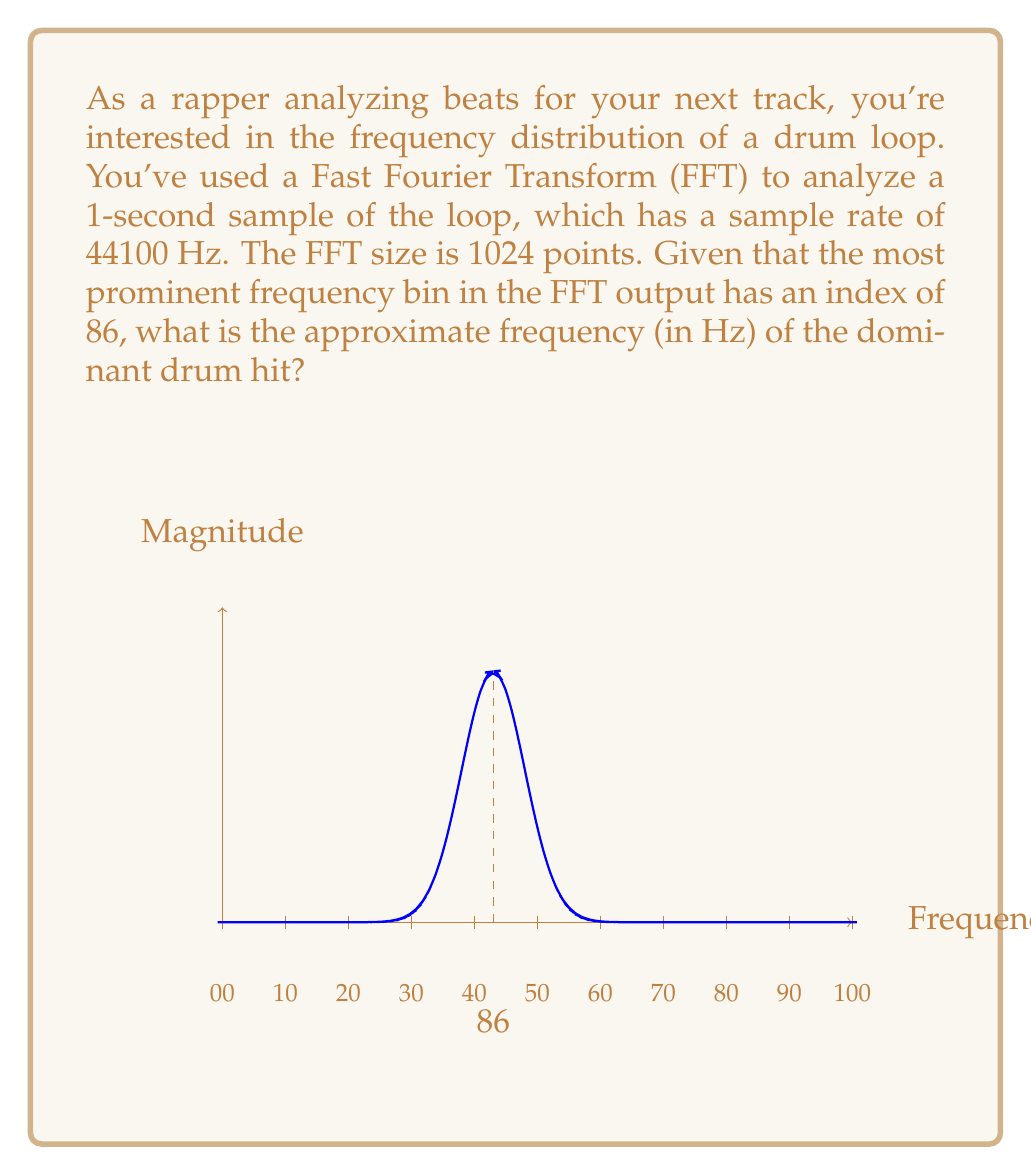Solve this math problem. To solve this problem, we'll follow these steps:

1) First, we need to understand the relationship between FFT bin index and frequency. The formula is:

   $$ f = \frac{k \cdot f_s}{N} $$

   Where:
   $f$ is the frequency in Hz
   $k$ is the bin index
   $f_s$ is the sample rate
   $N$ is the FFT size

2) We're given:
   $k = 86$ (the bin index)
   $f_s = 44100$ Hz (the sample rate)
   $N = 1024$ (the FFT size)

3) Let's substitute these values into our formula:

   $$ f = \frac{86 \cdot 44100}{1024} $$

4) Now we can calculate:

   $$ f = \frac{3792600}{1024} $$

5) Evaluating this:

   $$ f \approx 3703.71 \text{ Hz} $$

6) Rounding to the nearest whole number:

   $$ f \approx 3704 \text{ Hz} $$

This frequency (approximately 3704 Hz) represents the dominant frequency in your drum loop, likely corresponding to a prominent drum hit or cymbal crash.
Answer: 3704 Hz 